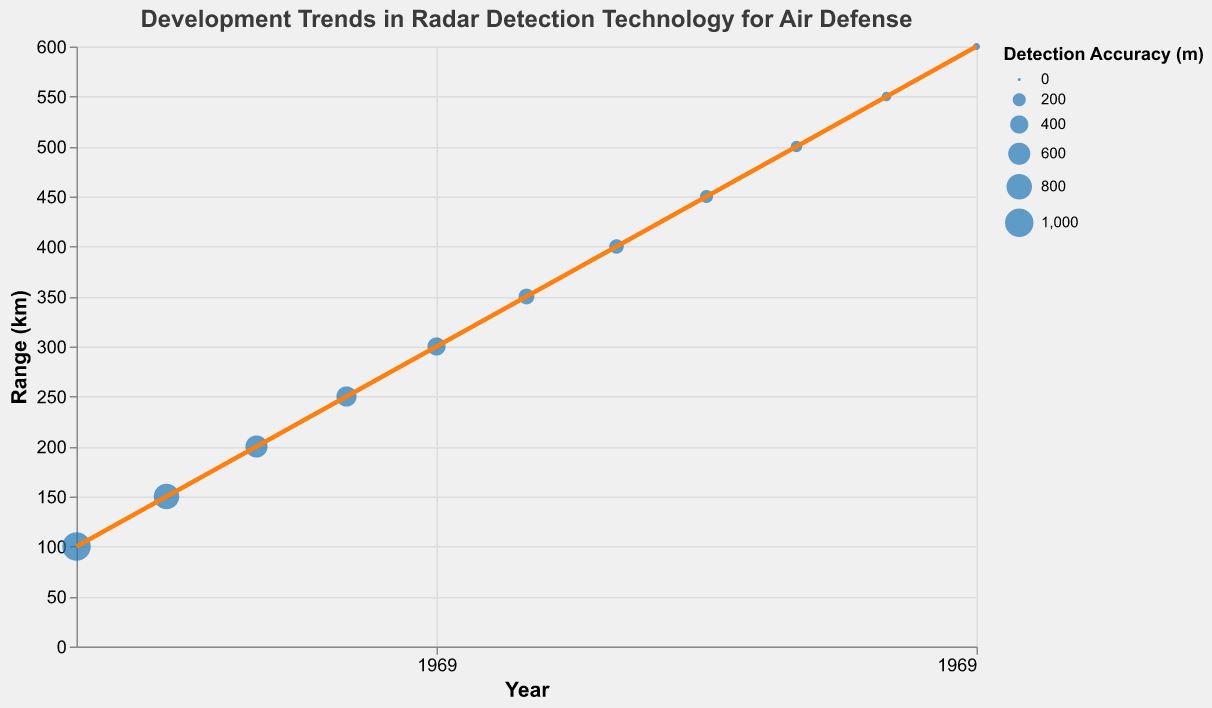When did the AN/TPS-43 system come into use? Locate the AN/TPS-43 system in the tooltip data and look at the corresponding year value.
Answer: 1980 Which radar system had the highest range in 1995? Find the data point for the year 1995 in the figure and check the tooltip to identify the radar system.
Answer: S-300 Radar 30N6E How does the detection accuracy trend over time? Notice that the detection accuracy changes inversely relative to the range. Over time, as the range increases, the detection accuracy improves (decreases in value). This can be seen in the size of the points getting smaller over the years.
Answer: Improves What is the range improvement from the SCR-584 radar in 1970 to the S-500 Radar 91N6E in 2020? Subtract the range value of the SCR-584 (100 km) from the range value of the S-500 Radar 91N6E (600 km).
Answer: 500 km Which radar system in 2005 had a range of 450 km and what was its detection accuracy? Look at the data point for the year 2005, then check the tooltip for that point to find the range and detection accuracy values.
Answer: S-400 Radar 92N6E, 200 m What is the trend line color and what does it represent? Observe the line color in the plot which typically represents the trend. The trend line color here is orange, which represents the regression line showing the trend in range over time.
Answer: Orange, range over time Between 1985 and 1990, by how much did the detection accuracy improve? Find the detection accuracy for Patriot Radar AN/MPQ-53 in 1985 (500 m) and AN/TPS-70 in 1990 (400 m). Subtract the 1990 accuracy from the 1985 accuracy.
Answer: 100 m How many years did it take for the range to double from the initial SCR-584 radar system used in 1970? Find the initial range (100 km in 1970), then locate the year when the range was 200 km.
Answer: 10 years (1980) Which radar system has the smallest detection accuracy, and when was it introduced? Look for the smallest detection accuracy value, which is associated with the smallest size point on the plot. Check the corresponding year and system in the tooltip.
Answer: S-500 Radar 91N6E, 2020 Is there a positive correlation between the year and the range according to the trend line? Observe the direction of the trend line, which is upward from left to right, indicating a positive correlation between the year and the range.
Answer: Yes 